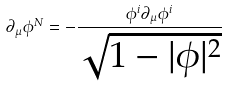Convert formula to latex. <formula><loc_0><loc_0><loc_500><loc_500>\partial _ { \mu } \phi ^ { N } = - \frac { \phi ^ { i } \partial _ { \mu } \phi ^ { i } } { \sqrt { 1 - | \phi | ^ { 2 } } }</formula> 